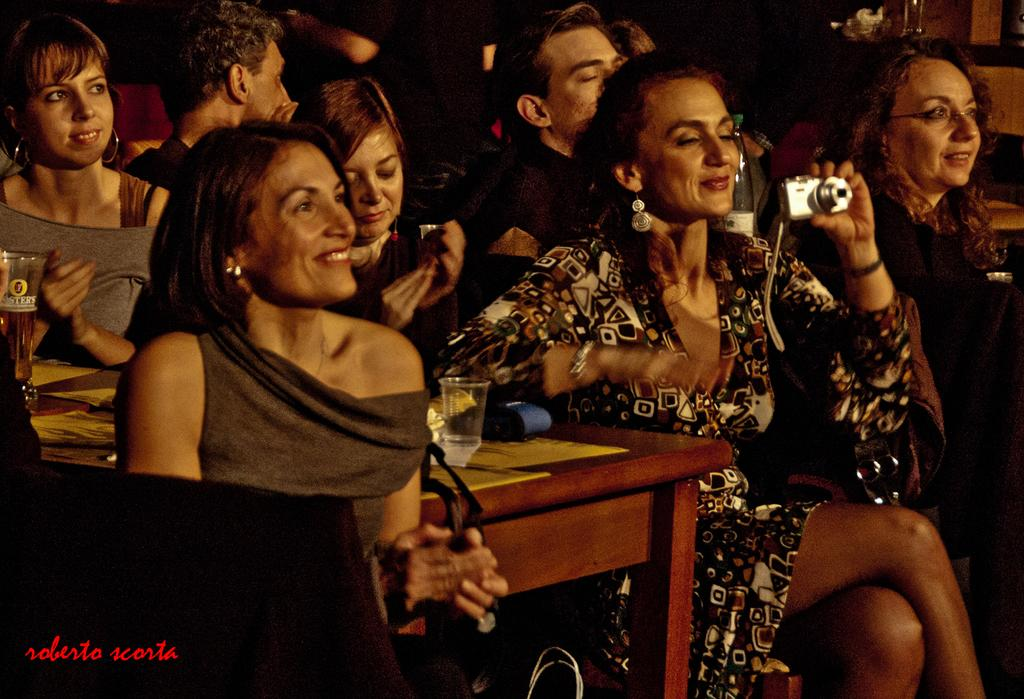What is the main subject of the image? The main subject of the image is a group of women. What are the women doing in the image? The women are sitting on chairs and smiling. What direction are the women looking in the image? The women are looking straight. Can you describe the position of the woman in the front of the group? The woman in the front of the group is taking photos with a camera. What type of goose can be seen in the image? There is no goose present in the image. How many wheels are visible in the image? There are no wheels visible in the image. 